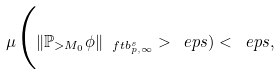Convert formula to latex. <formula><loc_0><loc_0><loc_500><loc_500>\mu \Big ( \| \mathbb { P } _ { > M _ { 0 } } \phi \| _ { \ f t { b } ^ { s } _ { p , \infty } } > \ e p s ) < \ e p s ,</formula> 